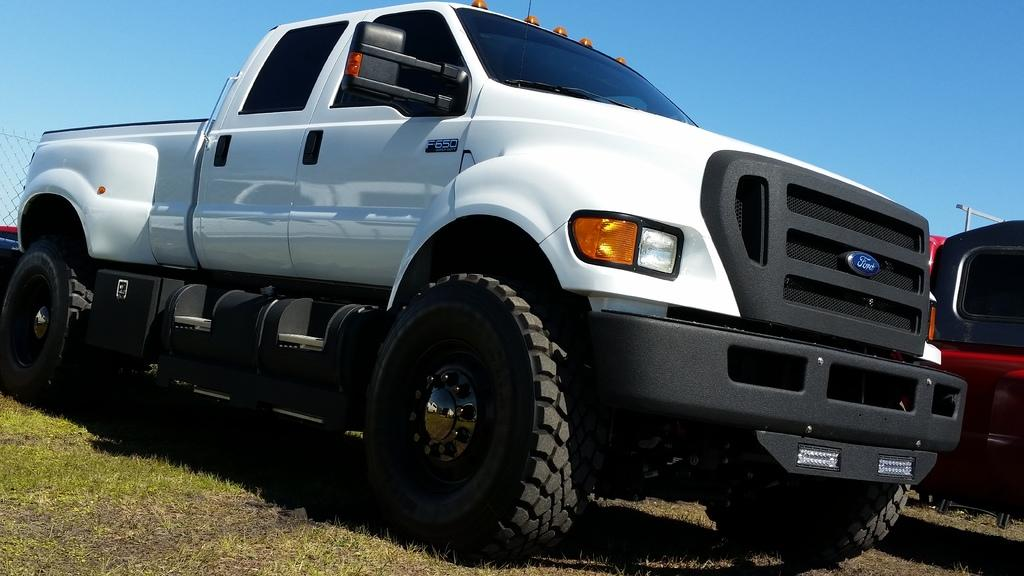What can be seen in the image related to transportation? There are vehicles in the image. What is located on the left side of the image? There is a fence on the left side of the image. What is visible at the top of the image? The sky is visible at the top of the image. What type of ground surface is present at the bottom of the image? Grass is present at the bottom of the image. Is there any text or writing visible in the image? Yes, there is text on one of the vehicles. Can you see any yarn being used in the image? There is no yarn present in the image. What type of holiday is being celebrated in the image? There is no indication of a holiday being celebrated in the image. Is there a volcano visible in the image? There is no volcano present in the image. 